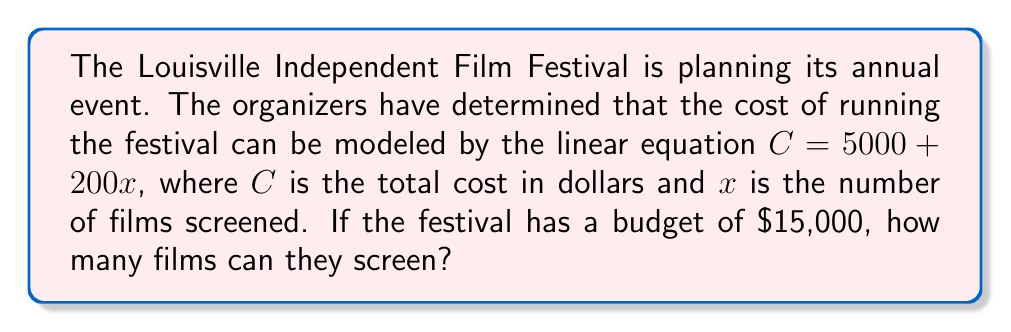Show me your answer to this math problem. Let's approach this step-by-step:

1) We're given the linear equation: $C = 5000 + 200x$
   Where $C$ is the total cost and $x$ is the number of films.

2) We know the budget is $15,000, so we can substitute this for $C$:
   $15000 = 5000 + 200x$

3) Now, we need to solve for $x$. First, let's subtract 5000 from both sides:
   $15000 - 5000 = 5000 - 5000 + 200x$
   $10000 = 200x$

4) Now, divide both sides by 200:
   $\frac{10000}{200} = \frac{200x}{200}$
   $50 = x$

5) Therefore, the festival can screen 50 films within their $15,000 budget.

6) We can verify this by plugging 50 back into the original equation:
   $C = 5000 + 200(50) = 5000 + 10000 = 15000$

This confirms our solution is correct.
Answer: 50 films 